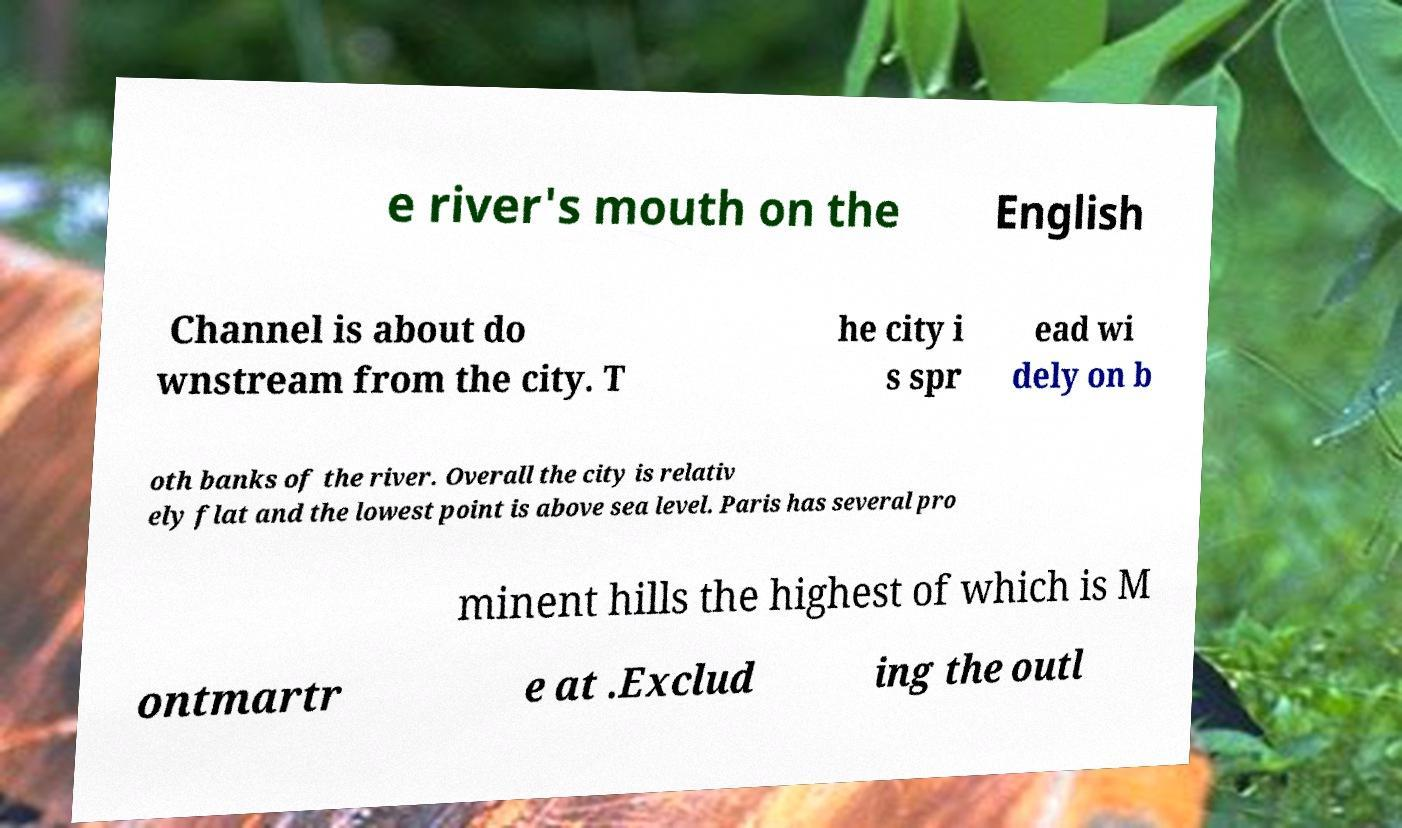What messages or text are displayed in this image? I need them in a readable, typed format. e river's mouth on the English Channel is about do wnstream from the city. T he city i s spr ead wi dely on b oth banks of the river. Overall the city is relativ ely flat and the lowest point is above sea level. Paris has several pro minent hills the highest of which is M ontmartr e at .Exclud ing the outl 